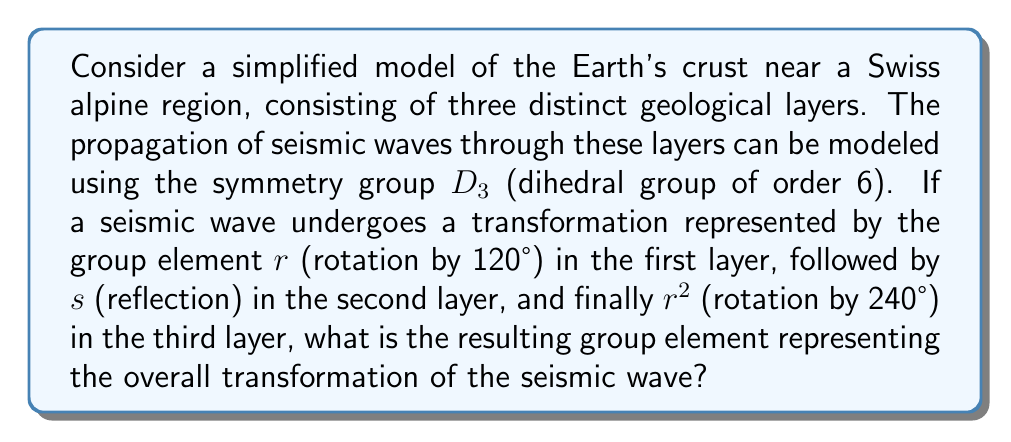What is the answer to this math problem? Let's approach this step-by-step:

1) First, recall that in the dihedral group $D_3$, we have:
   - Three rotations: $e$ (identity), $r$ (120° rotation), $r^2$ (240° rotation)
   - Three reflections: $s$, $rs$, $r^2s$

2) The problem gives us a sequence of transformations: $r$, then $s$, then $r^2$

3) In group theory, we compose these transformations from right to left. So we need to calculate:
   $r \cdot s \cdot r^2$

4) Let's break this down:
   - First, consider $s \cdot r^2$
   - In $D_3$, we have the relation $sr = r^2s$
   - Therefore, $s \cdot r^2 = r \cdot s$

5) Now our expression becomes:
   $r \cdot (r \cdot s)$

6) Simplify:
   $(r \cdot r) \cdot s = r^2 \cdot s$

7) In $D_3$, $r^2 \cdot s$ is one of the reflection elements, specifically the reflection across the axis that's 120° counterclockwise from the principal reflection axis.

Therefore, the overall transformation of the seismic wave is represented by the reflection element $r^2s$ in the group $D_3$.
Answer: $r^2s$ 